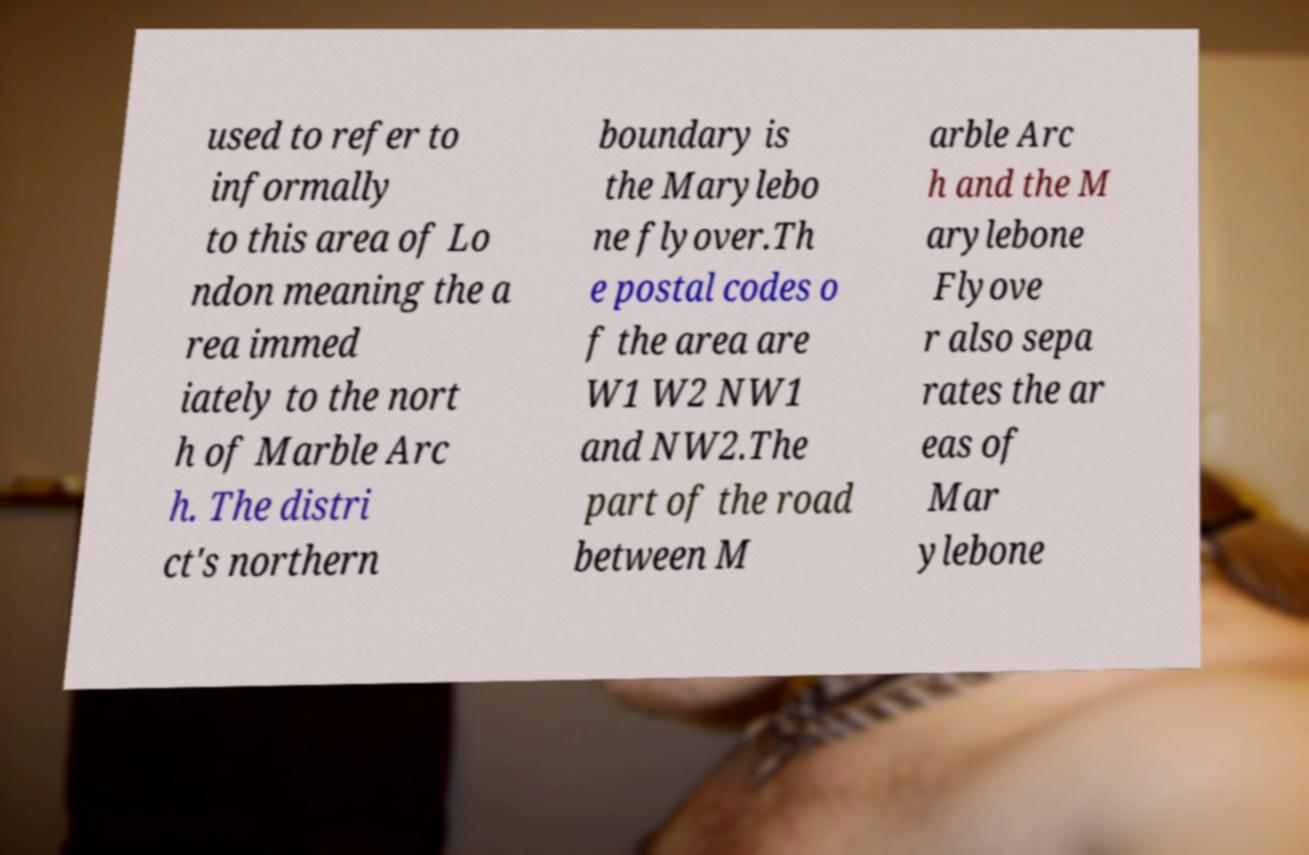Could you extract and type out the text from this image? used to refer to informally to this area of Lo ndon meaning the a rea immed iately to the nort h of Marble Arc h. The distri ct's northern boundary is the Marylebo ne flyover.Th e postal codes o f the area are W1 W2 NW1 and NW2.The part of the road between M arble Arc h and the M arylebone Flyove r also sepa rates the ar eas of Mar ylebone 